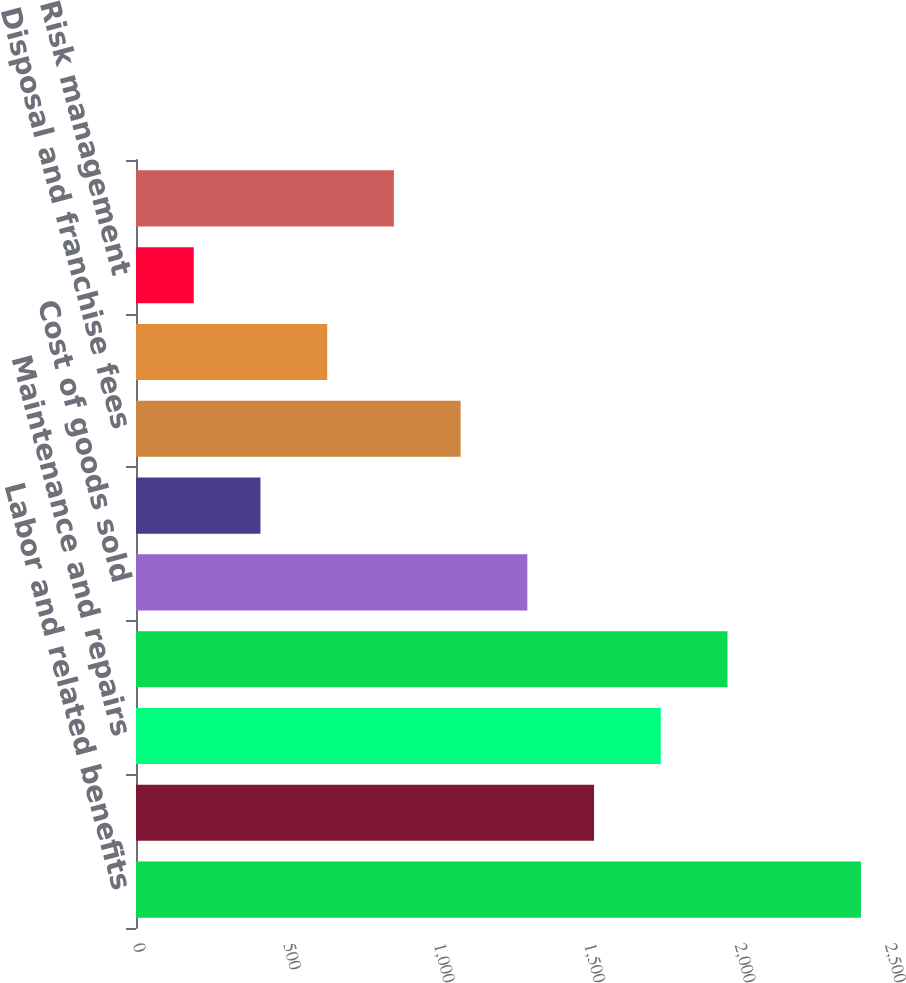<chart> <loc_0><loc_0><loc_500><loc_500><bar_chart><fcel>Labor and related benefits<fcel>Transfer and disposal costs<fcel>Maintenance and repairs<fcel>Subcontractor costs<fcel>Cost of goods sold<fcel>Fuel<fcel>Disposal and franchise fees<fcel>Landfill operating costs<fcel>Risk management<fcel>Other<nl><fcel>2410<fcel>1522.8<fcel>1744.6<fcel>1966.4<fcel>1301<fcel>413.8<fcel>1079.2<fcel>635.6<fcel>192<fcel>857.4<nl></chart> 